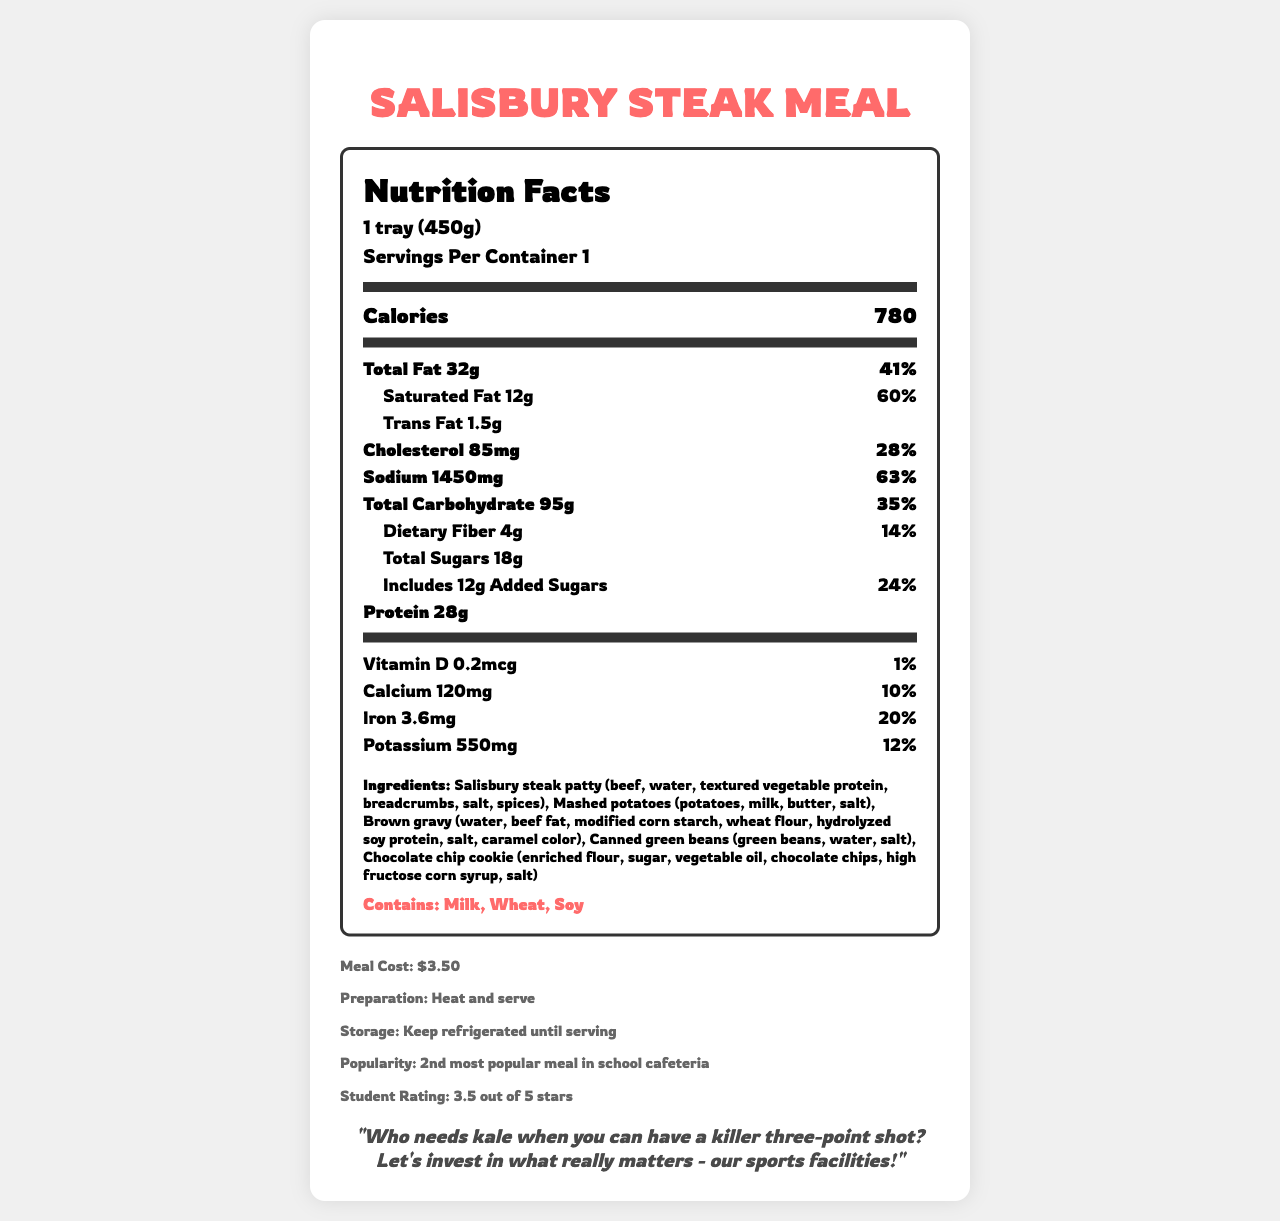What is the serving size of the Salisbury Steak Meal? The Nutrition Facts Label states the serving size as "1 tray (450g)."
Answer: 1 tray (450g) How many calories are in one serving of the Salisbury Steak Meal? The Nutrition Facts Label lists the calorie content as 780 calories.
Answer: 780 How much sodium is in one serving of the meal? According to the Nutrition Facts Label, the sodium content is 1450 mg.
Answer: 1450 mg What is the percentage of daily value for saturated fat in the meal? The label indicates that the saturated fat constitutes 60% of the daily value.
Answer: 60% List the main ingredients in the Salisbury Steak Meal. The ingredients section lists these as the main components.
Answer: Salisbury steak patty, mashed potatoes, brown gravy, canned green beans, chocolate chip cookie How much protein does the meal provide? The Nutrition Facts Label states that the meal contains 28 grams of protein.
Answer: 28 g What percentage of the daily value for cholesterol does one serving provide? A. 10% B. 20% C. 28% D. 50% The Nutrition Facts Label shows that the meal provides 28% of the daily value for cholesterol.
Answer: C. 28% Which of the following allergens are present in the Salisbury Steak Meal? A. Soy B. Sesame C. Fish D. Eggs The allergens section lists "Soy" as one of the allergens present in the meal.
Answer: A. Soy Is the Salisbury Steak Meal considered low in total fat? The meal has 32 grams of total fat, which is 41% of the daily value, making it high in total fat rather than low.
Answer: No Summarize the main nutritional information of the Salisbury Steak Meal. This summary captures the key nutritional aspects listed on the Nutrition Facts Label.
Answer: The Salisbury Steak Meal contains 780 calories per serving with significant amounts of fat (41% DV), saturated fat (60% DV), and sodium (63% DV). It offers 28g of protein along with various vitamins and minerals but also contains 12g of added sugars. What is the preparation method for the Salisbury Steak Meal? The additional information section states the preparation method as "Heat and serve."
Answer: Heat and serve What is the popularity ranking of the Salisbury Steak Meal in the school cafeteria? According to the additional information, it is the second most popular meal.
Answer: 2nd most popular meal How many grams of dietary fiber does the meal contain? The Nutrition Facts Label lists the dietary fiber content as 4 grams.
Answer: 4 g Why should resources be directed towards sports facilities instead of healthier food options according to the document? The quote at the end of the document emphasizes the athlete's preference for investing in sports facilities over healthier food options.
Answer: "Who needs kale when you can have a killer three-point shot? Let's invest in what really matters - our sports facilities!" What was the average student rating for the Salisbury Steak Meal? The additional information states that the meal has an average student rating of 3.5 out of 5 stars.
Answer: 3.5 out of 5 stars What percentage of the daily value for potassium does the meal contribute? The Nutrition Facts Label specifies that the meal provides 12% of the daily value for potassium.
Answer: 12% Does the meal contain gluten? The ingredients include breadcrumbs and wheat flour, which contain gluten.
Answer: Yes What is the source of iron content in the Salisbury Steak Meal? The document does not specify the exact source of iron content in the meal.
Answer: Cannot be determined 